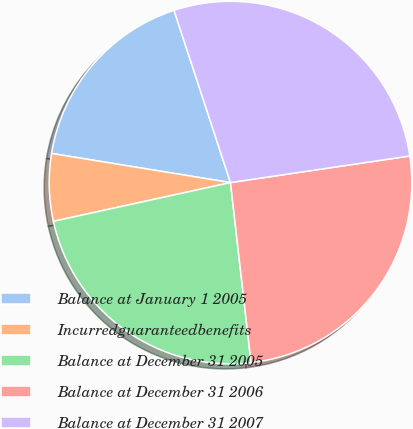<chart> <loc_0><loc_0><loc_500><loc_500><pie_chart><fcel>Balance at January 1 2005<fcel>Incurredguaranteedbenefits<fcel>Balance at December 31 2005<fcel>Balance at December 31 2006<fcel>Balance at December 31 2007<nl><fcel>17.39%<fcel>6.0%<fcel>23.38%<fcel>25.54%<fcel>27.7%<nl></chart> 